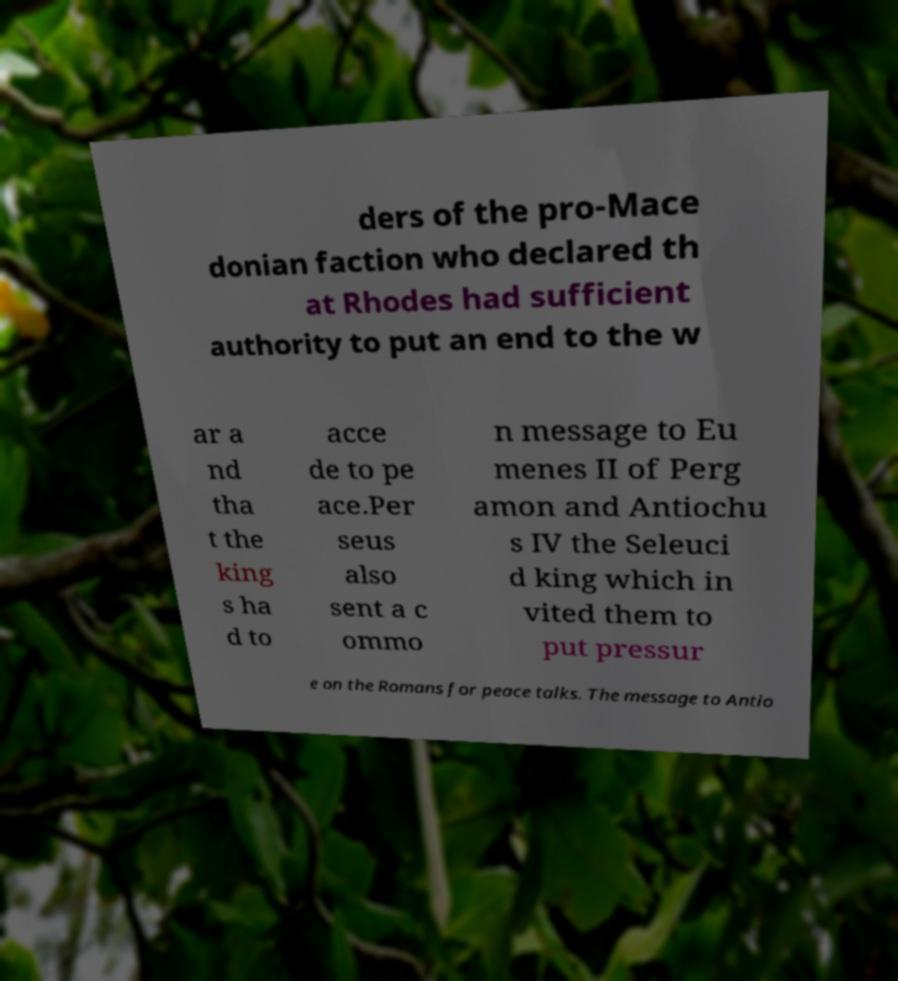There's text embedded in this image that I need extracted. Can you transcribe it verbatim? ders of the pro-Mace donian faction who declared th at Rhodes had sufficient authority to put an end to the w ar a nd tha t the king s ha d to acce de to pe ace.Per seus also sent a c ommo n message to Eu menes II of Perg amon and Antiochu s IV the Seleuci d king which in vited them to put pressur e on the Romans for peace talks. The message to Antio 